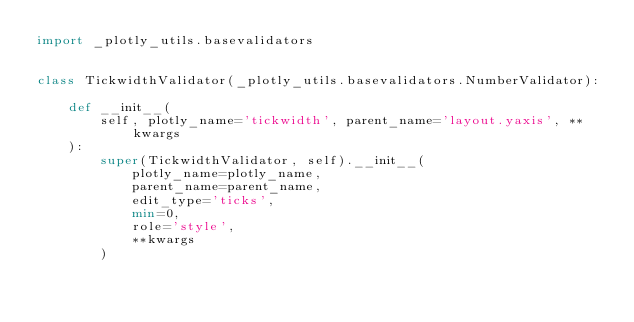Convert code to text. <code><loc_0><loc_0><loc_500><loc_500><_Python_>import _plotly_utils.basevalidators


class TickwidthValidator(_plotly_utils.basevalidators.NumberValidator):

    def __init__(
        self, plotly_name='tickwidth', parent_name='layout.yaxis', **kwargs
    ):
        super(TickwidthValidator, self).__init__(
            plotly_name=plotly_name,
            parent_name=parent_name,
            edit_type='ticks',
            min=0,
            role='style',
            **kwargs
        )
</code> 